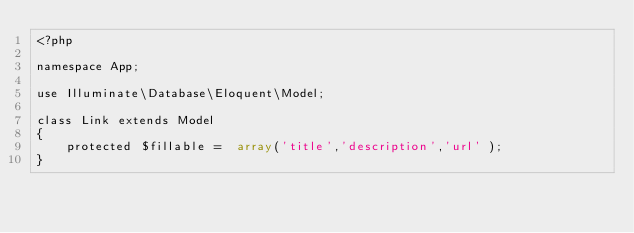Convert code to text. <code><loc_0><loc_0><loc_500><loc_500><_PHP_><?php

namespace App;

use Illuminate\Database\Eloquent\Model;

class Link extends Model
{
    protected $fillable =  array('title','description','url' );
}
</code> 